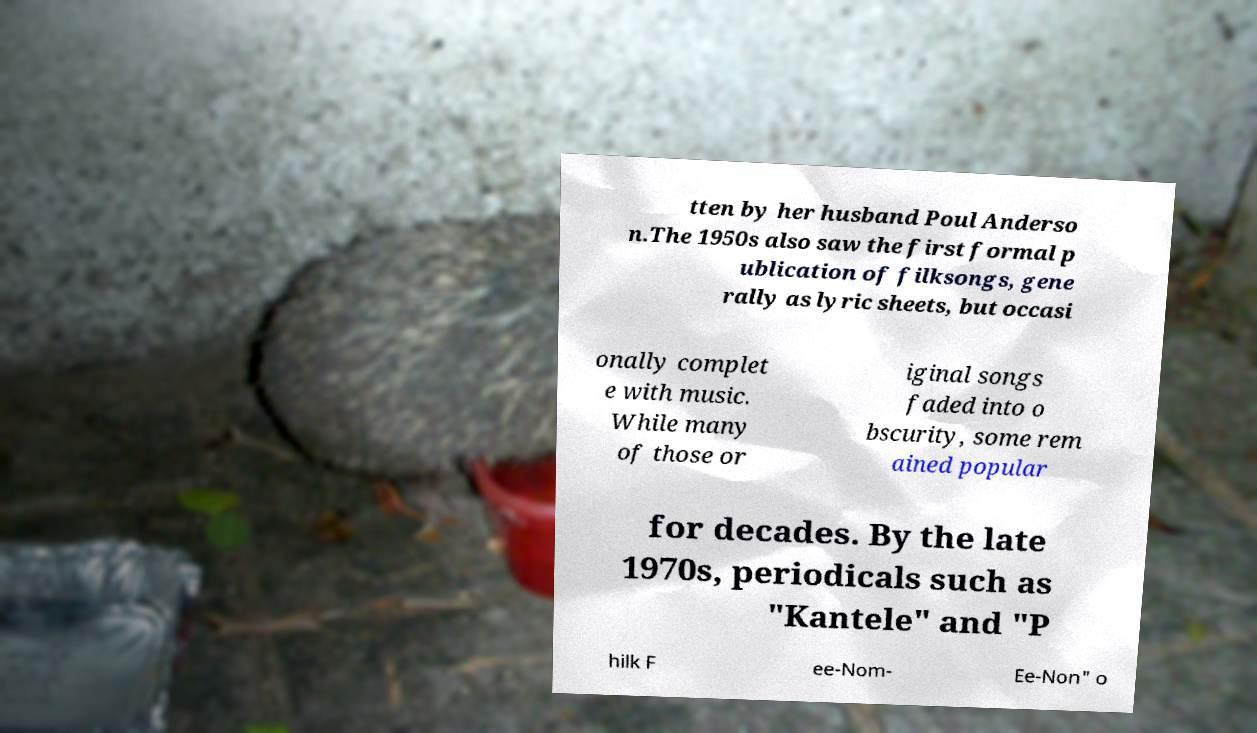Could you extract and type out the text from this image? tten by her husband Poul Anderso n.The 1950s also saw the first formal p ublication of filksongs, gene rally as lyric sheets, but occasi onally complet e with music. While many of those or iginal songs faded into o bscurity, some rem ained popular for decades. By the late 1970s, periodicals such as "Kantele" and "P hilk F ee-Nom- Ee-Non" o 